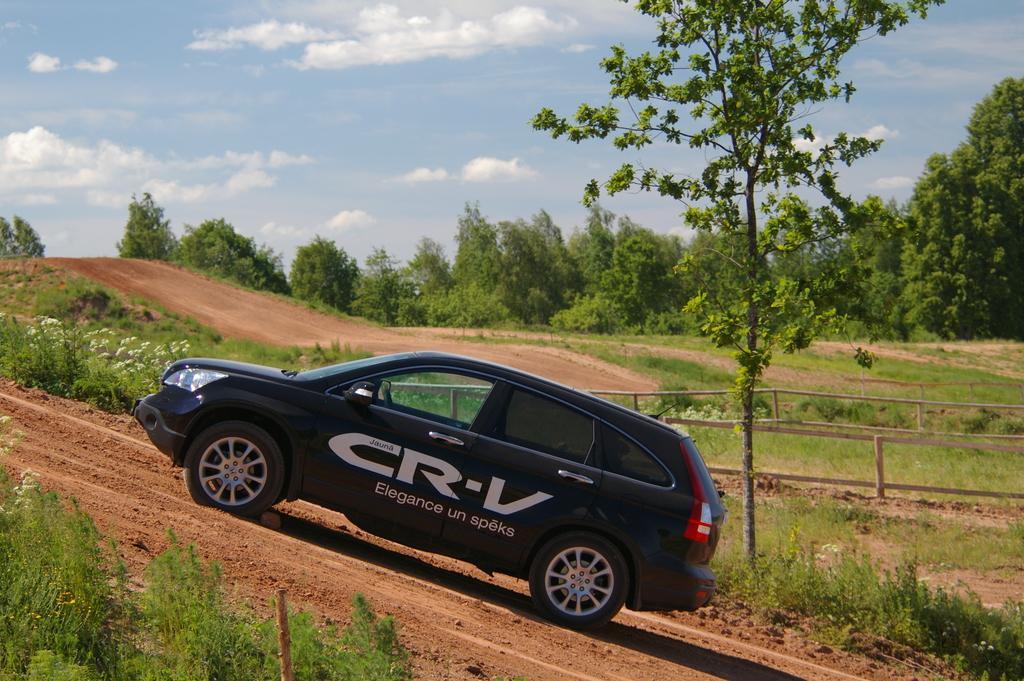Could you give a brief overview of what you see in this image? This picture shows a black color car and we see trees and plants and a blue cloudy Sky. 